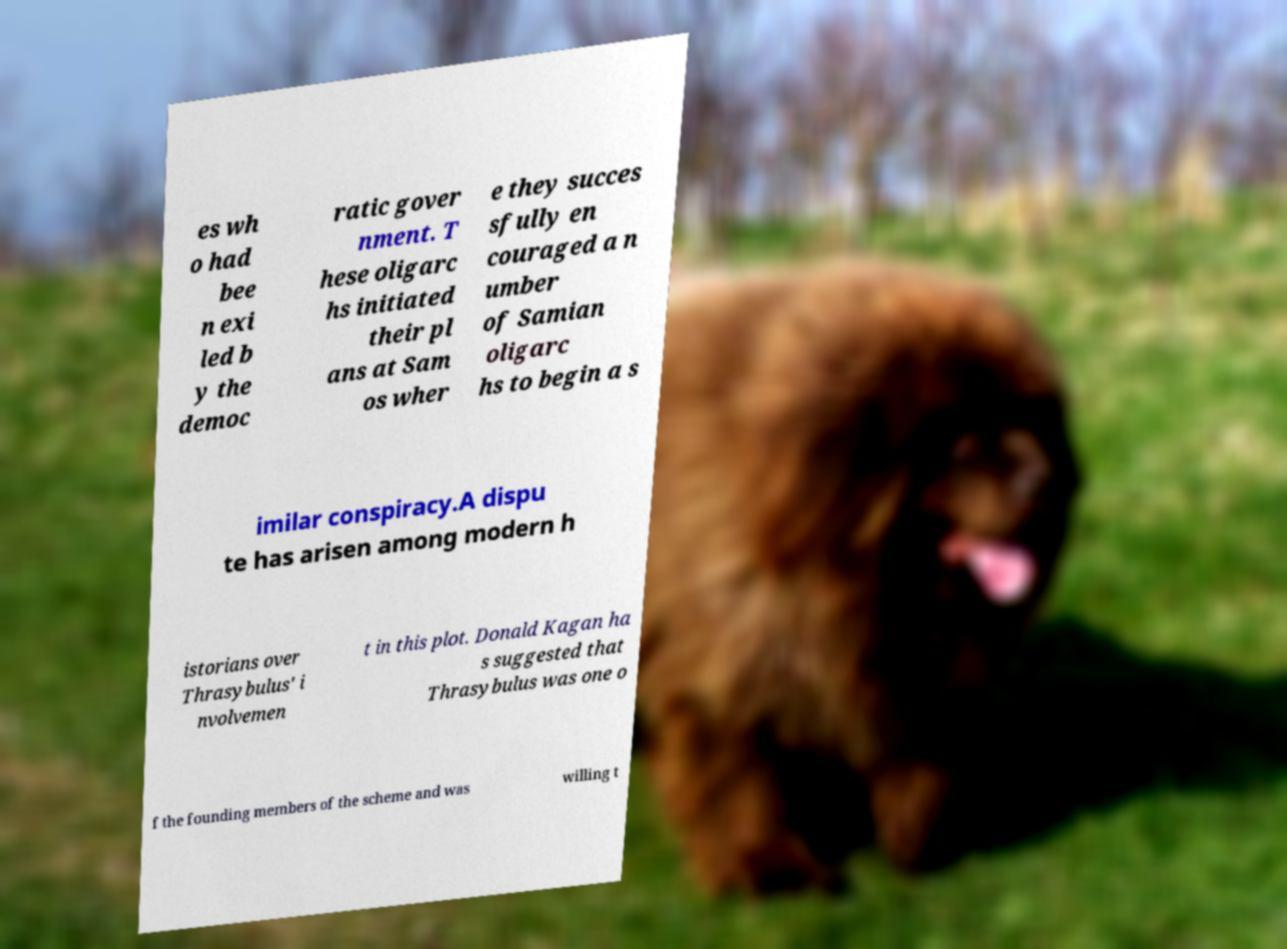Could you extract and type out the text from this image? es wh o had bee n exi led b y the democ ratic gover nment. T hese oligarc hs initiated their pl ans at Sam os wher e they succes sfully en couraged a n umber of Samian oligarc hs to begin a s imilar conspiracy.A dispu te has arisen among modern h istorians over Thrasybulus' i nvolvemen t in this plot. Donald Kagan ha s suggested that Thrasybulus was one o f the founding members of the scheme and was willing t 